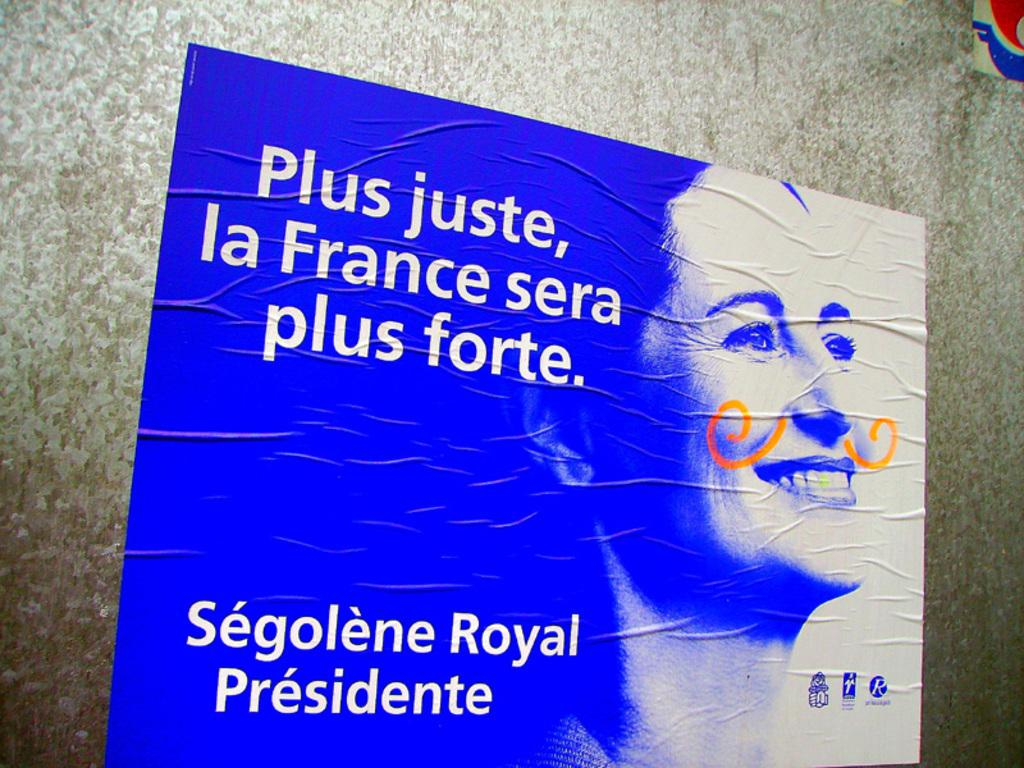What is featured on the poster in the image? The poster has an image of a lady. Is there any text on the poster? Yes, there is text on the poster. What can be seen in the background of the image? There is a wall in the background of the image. What type of cakes are being played on the guitar in the image? There is no guitar or cakes present in the image; it features a poster with an image of a lady and text. 